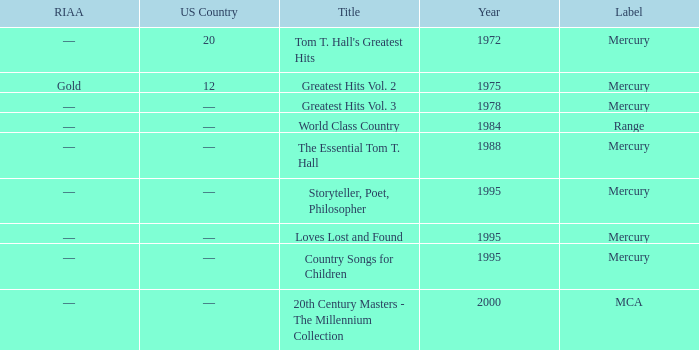What is the highest year for the title, "loves lost and found"? 1995.0. 